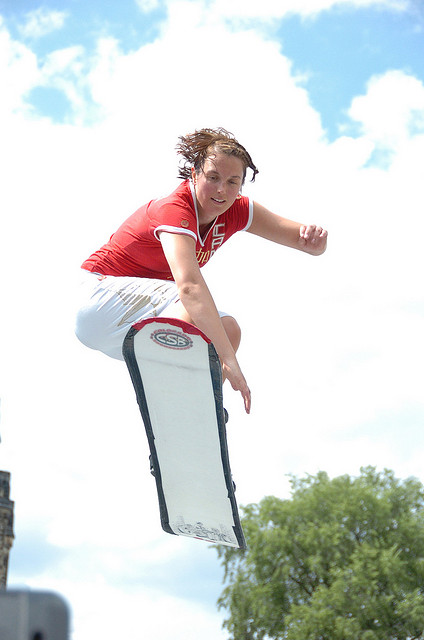Please extract the text content from this image. CSB 